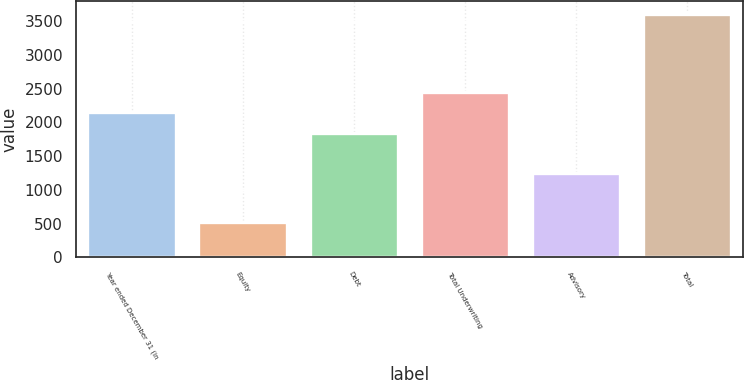Convert chart. <chart><loc_0><loc_0><loc_500><loc_500><bar_chart><fcel>Year ended December 31 (in<fcel>Equity<fcel>Debt<fcel>Total Underwriting<fcel>Advisory<fcel>Total<nl><fcel>2147.7<fcel>525<fcel>1839<fcel>2456.4<fcel>1248<fcel>3612<nl></chart> 